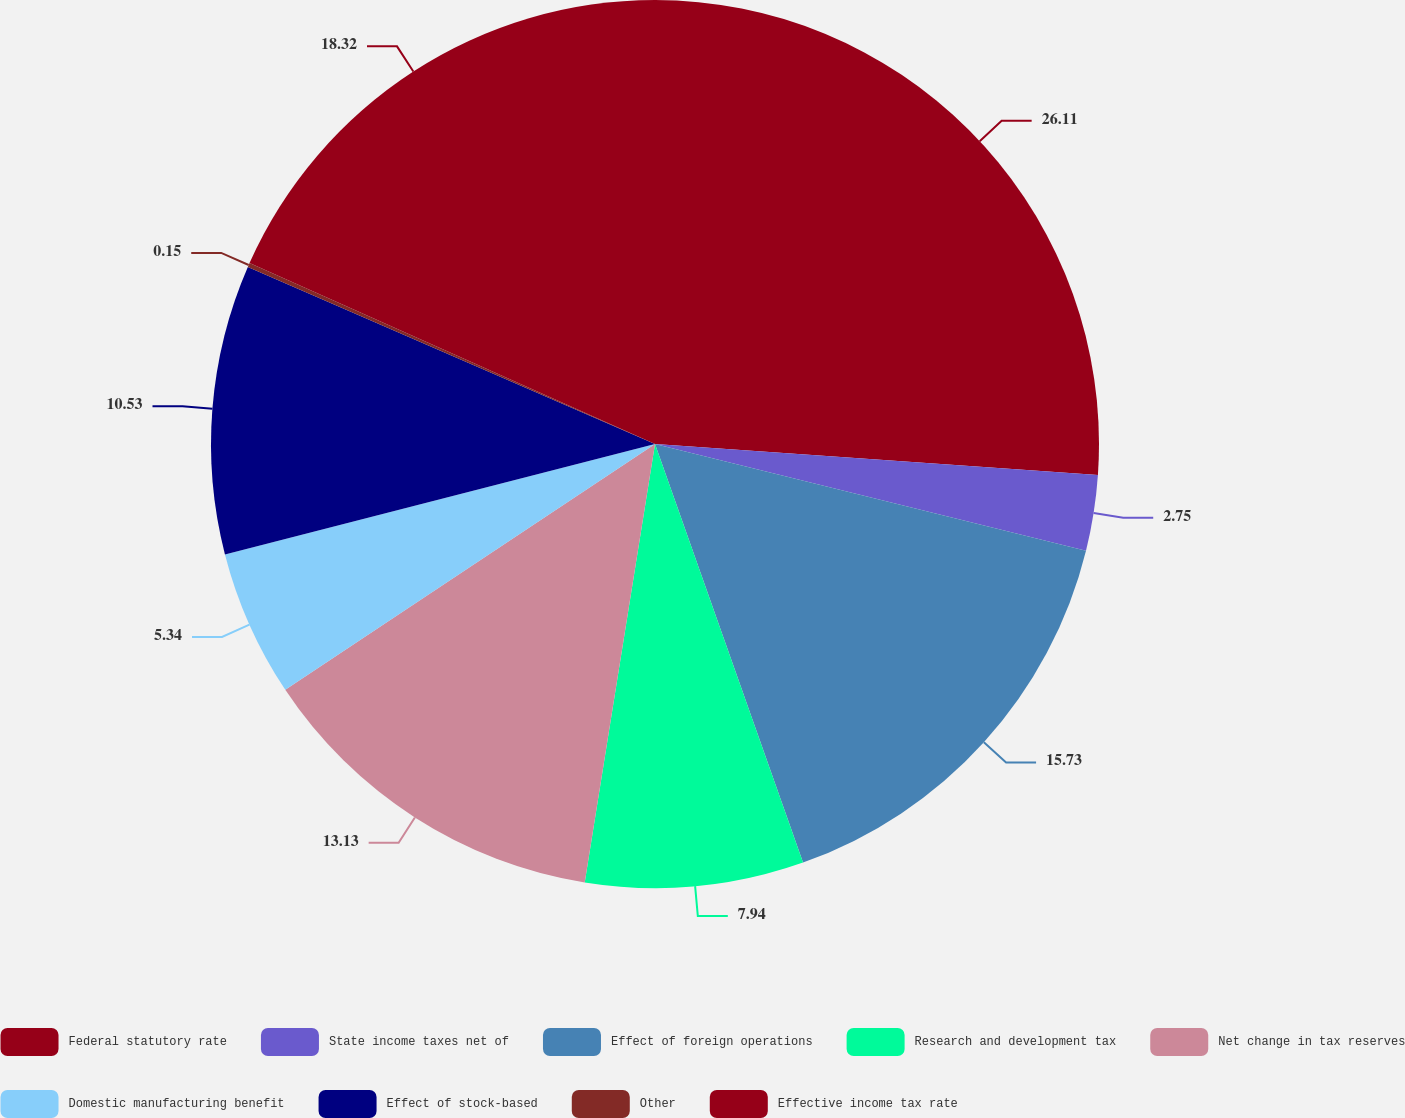Convert chart. <chart><loc_0><loc_0><loc_500><loc_500><pie_chart><fcel>Federal statutory rate<fcel>State income taxes net of<fcel>Effect of foreign operations<fcel>Research and development tax<fcel>Net change in tax reserves<fcel>Domestic manufacturing benefit<fcel>Effect of stock-based<fcel>Other<fcel>Effective income tax rate<nl><fcel>26.11%<fcel>2.75%<fcel>15.73%<fcel>7.94%<fcel>13.13%<fcel>5.34%<fcel>10.53%<fcel>0.15%<fcel>18.32%<nl></chart> 